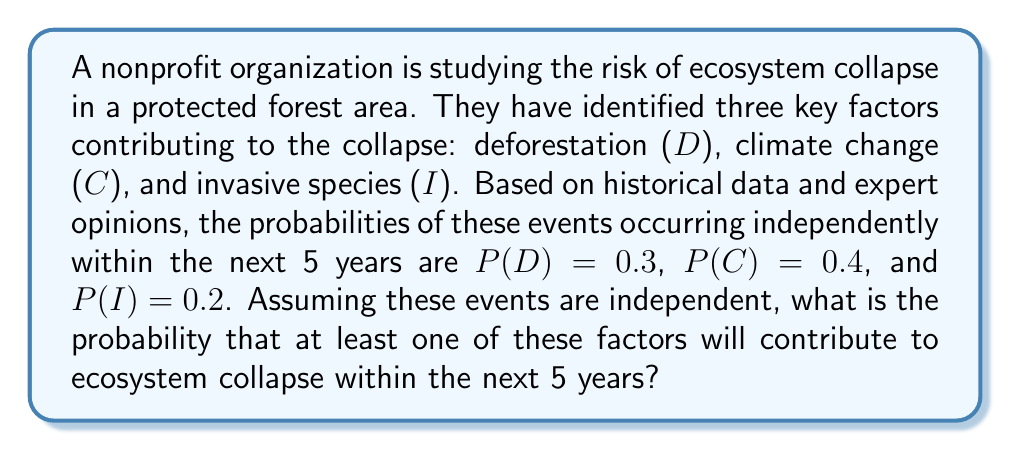What is the answer to this math problem? To solve this problem, we'll use the concept of probability of the union of events and the complement rule.

Step 1: Define the event we're looking for
Let E be the event that at least one factor contributes to ecosystem collapse.

Step 2: Express the probability using the complement rule
The probability of at least one factor contributing is equal to 1 minus the probability that none of the factors contribute.

$$P(E) = 1 - P(\text{no factors contribute})$$

Step 3: Calculate the probability that no factors contribute
Since the events are independent, we can multiply the probabilities of each factor not occurring:

$$P(\text{no factors contribute}) = (1-P(D)) \times (1-P(C)) \times (1-P(I))$$

Step 4: Substitute the given probabilities
$$(1-0.3) \times (1-0.4) \times (1-0.2) = 0.7 \times 0.6 \times 0.8$$

Step 5: Compute the result
$$0.7 \times 0.6 \times 0.8 = 0.336$$

Step 6: Calculate the final probability
$$P(E) = 1 - 0.336 = 0.664$$

Therefore, the probability that at least one factor will contribute to ecosystem collapse within the next 5 years is 0.664 or 66.4%.
Answer: 0.664 